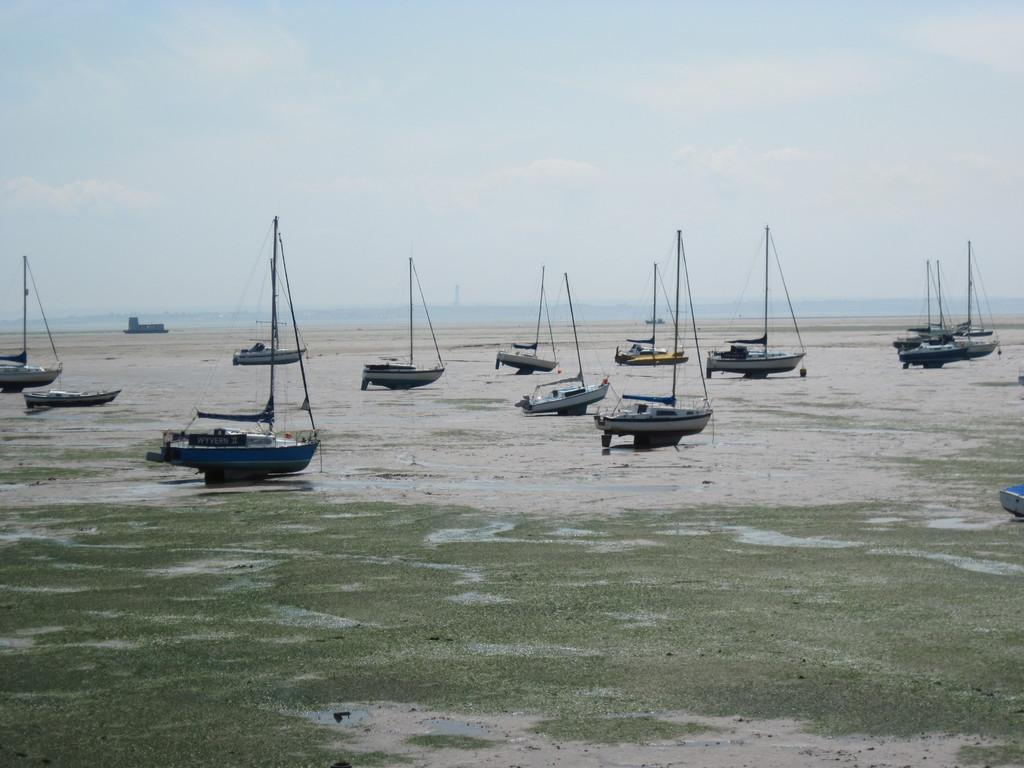What is the main subject of the image? The main subject of the image is many boards. How are the boards positioned in the image? The boards are kept on the ground. What type of surface can be seen in the image? There is ground visible in the image. What can be seen in the background of the image? There is water in the background of the image. What is visible at the top of the image? The sky is visible at the top of the image. What type of art can be seen hanging from the throat of the person in the image? There is no person or throat present in the image; it features many boards on the ground. Is there a club visible in the image? There is no club present in the image. 